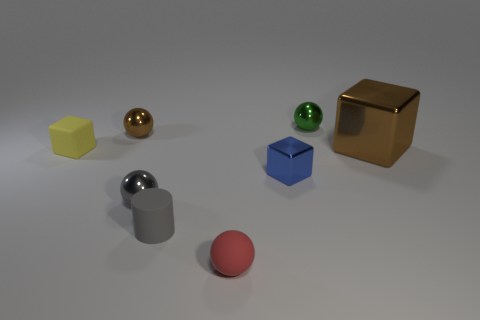Are there any other things that are the same size as the brown metal cube?
Provide a short and direct response. No. Is there anything else that is the same shape as the gray matte object?
Your answer should be compact. No. There is a tiny shiny sphere in front of the big brown shiny object; what is its color?
Ensure brevity in your answer.  Gray. There is a gray matte thing that is the same size as the blue cube; what shape is it?
Provide a succinct answer. Cylinder. Is the color of the small cylinder the same as the metallic ball in front of the small blue object?
Ensure brevity in your answer.  Yes. How many things are either tiny shiny spheres that are right of the gray sphere or matte objects that are left of the red rubber ball?
Provide a succinct answer. 3. What material is the brown sphere that is the same size as the blue block?
Your response must be concise. Metal. What number of other objects are there of the same material as the big brown object?
Provide a succinct answer. 4. There is a small red object that is to the right of the tiny gray metal ball; is it the same shape as the gray thing that is to the left of the tiny gray cylinder?
Provide a succinct answer. Yes. What color is the tiny thing that is to the left of the brown metallic thing that is on the left side of the shiny ball that is right of the gray cylinder?
Offer a terse response. Yellow. 